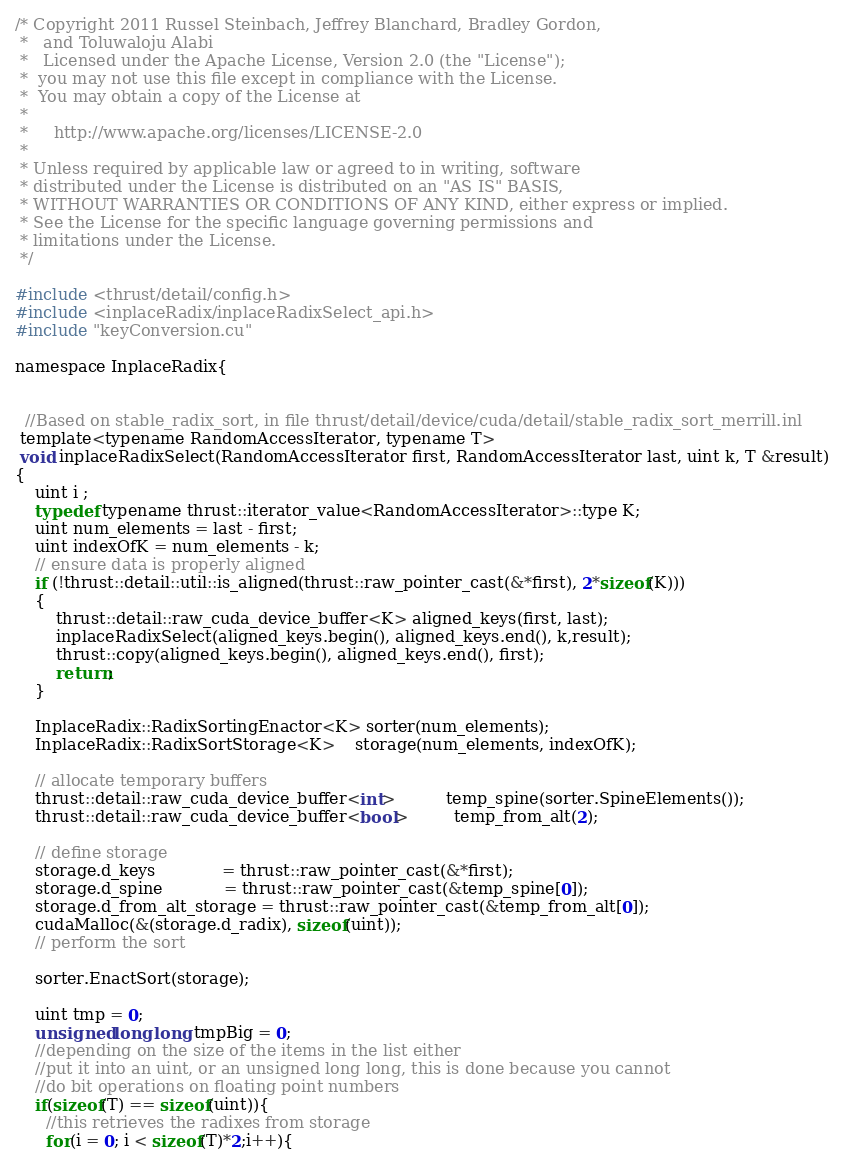Convert code to text. <code><loc_0><loc_0><loc_500><loc_500><_Cuda_>/* Copyright 2011 Russel Steinbach, Jeffrey Blanchard, Bradley Gordon,
 *   and Toluwaloju Alabi
 *   Licensed under the Apache License, Version 2.0 (the "License");
 *  you may not use this file except in compliance with the License.
 *  You may obtain a copy of the License at
 *
 *     http://www.apache.org/licenses/LICENSE-2.0
 *     
 * Unless required by applicable law or agreed to in writing, software
 * distributed under the License is distributed on an "AS IS" BASIS,
 * WITHOUT WARRANTIES OR CONDITIONS OF ANY KIND, either express or implied.
 * See the License for the specific language governing permissions and
 * limitations under the License.
 */

#include <thrust/detail/config.h>
#include <inplaceRadix/inplaceRadixSelect_api.h>
#include "keyConversion.cu"

namespace InplaceRadix{


  //Based on stable_radix_sort, in file thrust/detail/device/cuda/detail/stable_radix_sort_merrill.inl
 template<typename RandomAccessIterator, typename T>
 void inplaceRadixSelect(RandomAccessIterator first, RandomAccessIterator last, uint k, T &result)
{
    uint i ;
    typedef typename thrust::iterator_value<RandomAccessIterator>::type K;
    uint num_elements = last - first;
    uint indexOfK = num_elements - k;
    // ensure data is properly aligned
    if (!thrust::detail::util::is_aligned(thrust::raw_pointer_cast(&*first), 2*sizeof(K)))
    {
        thrust::detail::raw_cuda_device_buffer<K> aligned_keys(first, last);
        inplaceRadixSelect(aligned_keys.begin(), aligned_keys.end(), k,result);
        thrust::copy(aligned_keys.begin(), aligned_keys.end(), first);
        return;
    }
    
    InplaceRadix::RadixSortingEnactor<K> sorter(num_elements);
    InplaceRadix::RadixSortStorage<K>    storage(num_elements, indexOfK);
    
    // allocate temporary buffers
    thrust::detail::raw_cuda_device_buffer<int>          temp_spine(sorter.SpineElements());
    thrust::detail::raw_cuda_device_buffer<bool>         temp_from_alt(2);

    // define storage
    storage.d_keys             = thrust::raw_pointer_cast(&*first);
    storage.d_spine            = thrust::raw_pointer_cast(&temp_spine[0]);
    storage.d_from_alt_storage = thrust::raw_pointer_cast(&temp_from_alt[0]);
    cudaMalloc(&(storage.d_radix), sizeof(uint));
    // perform the sort

    sorter.EnactSort(storage);

    uint tmp = 0;
    unsigned long long tmpBig = 0;
    //depending on the size of the items in the list either
    //put it into an uint, or an unsigned long long, this is done because you cannot 
    //do bit operations on floating point numbers
    if(sizeof(T) == sizeof(uint)){
      //this retrieves the radixes from storage
      for(i = 0; i < sizeof(T)*2;i++){</code> 